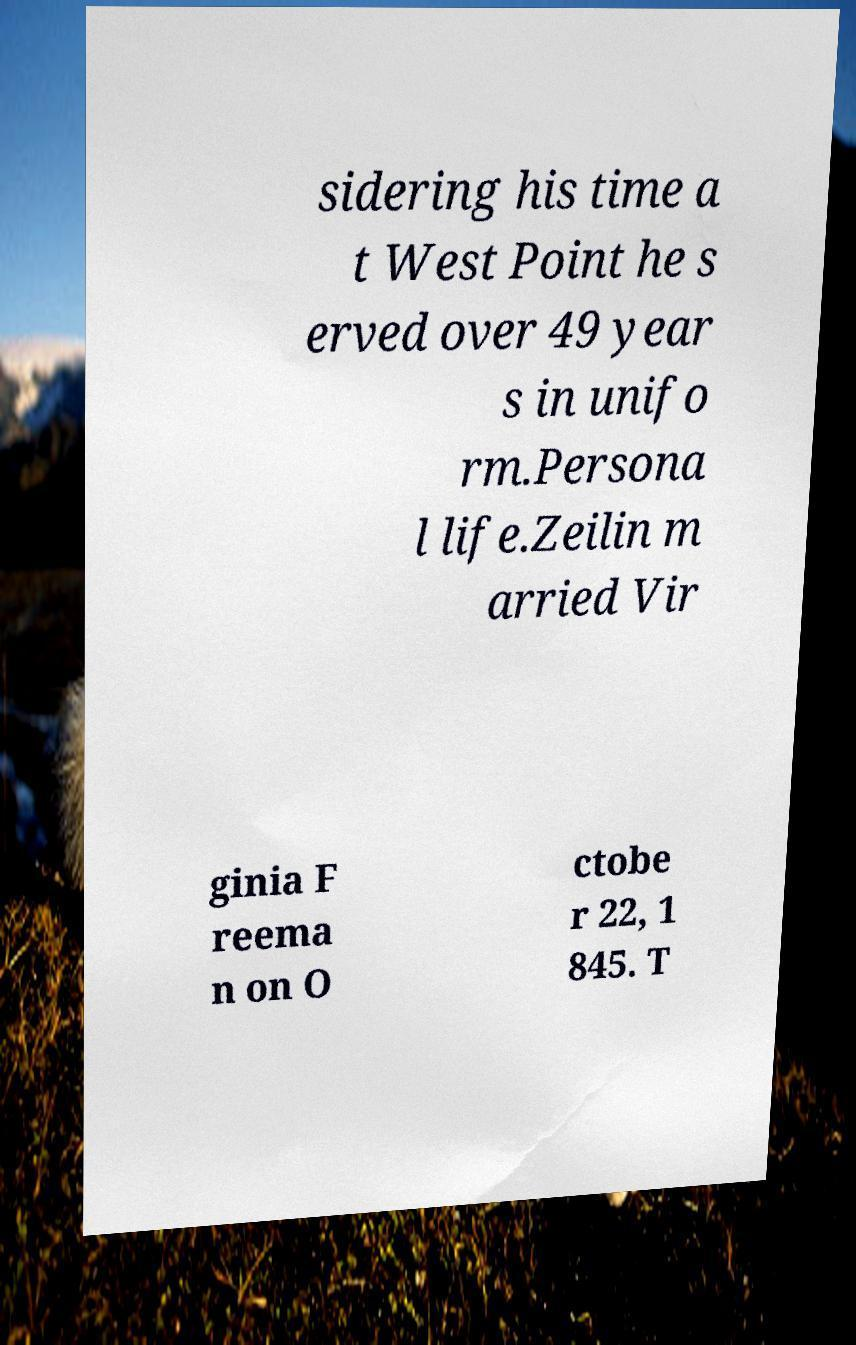Please read and relay the text visible in this image. What does it say? sidering his time a t West Point he s erved over 49 year s in unifo rm.Persona l life.Zeilin m arried Vir ginia F reema n on O ctobe r 22, 1 845. T 